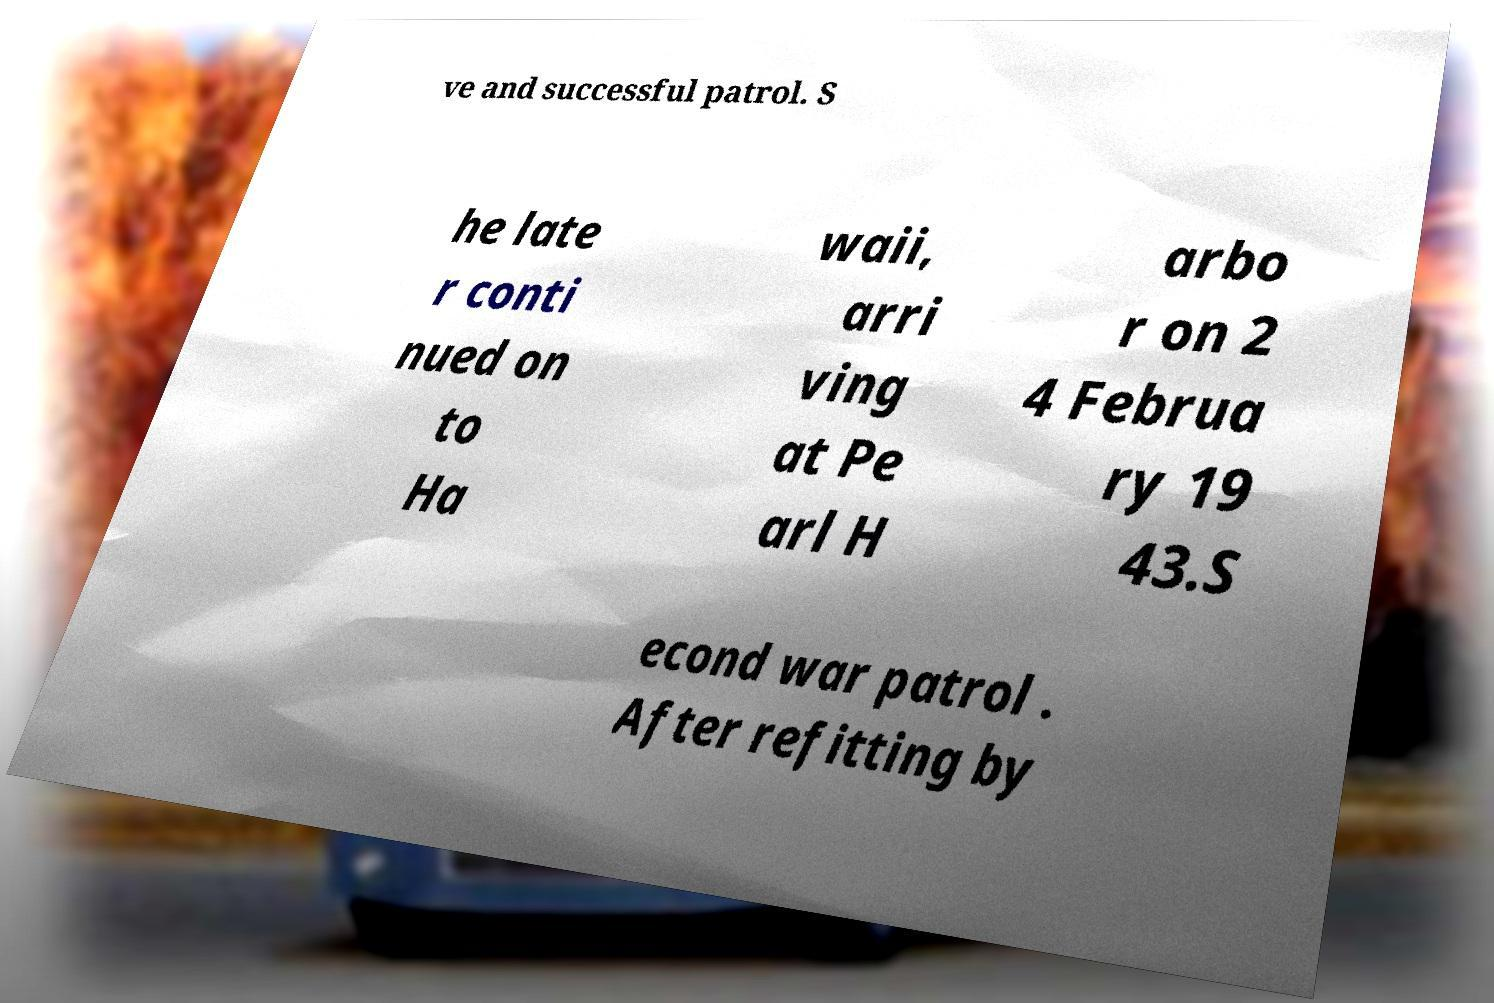Could you assist in decoding the text presented in this image and type it out clearly? ve and successful patrol. S he late r conti nued on to Ha waii, arri ving at Pe arl H arbo r on 2 4 Februa ry 19 43.S econd war patrol . After refitting by 